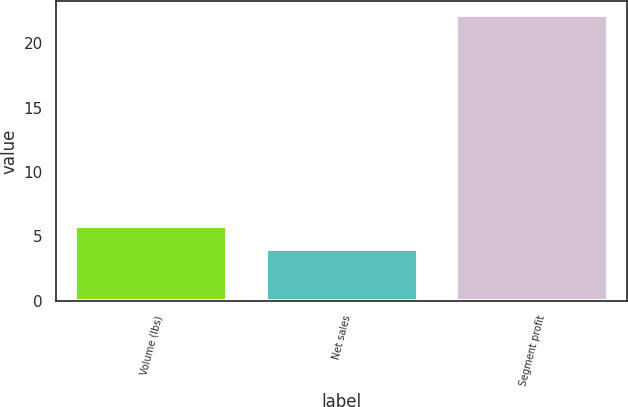Convert chart to OTSL. <chart><loc_0><loc_0><loc_500><loc_500><bar_chart><fcel>Volume (lbs)<fcel>Net sales<fcel>Segment profit<nl><fcel>5.82<fcel>4<fcel>22.2<nl></chart> 